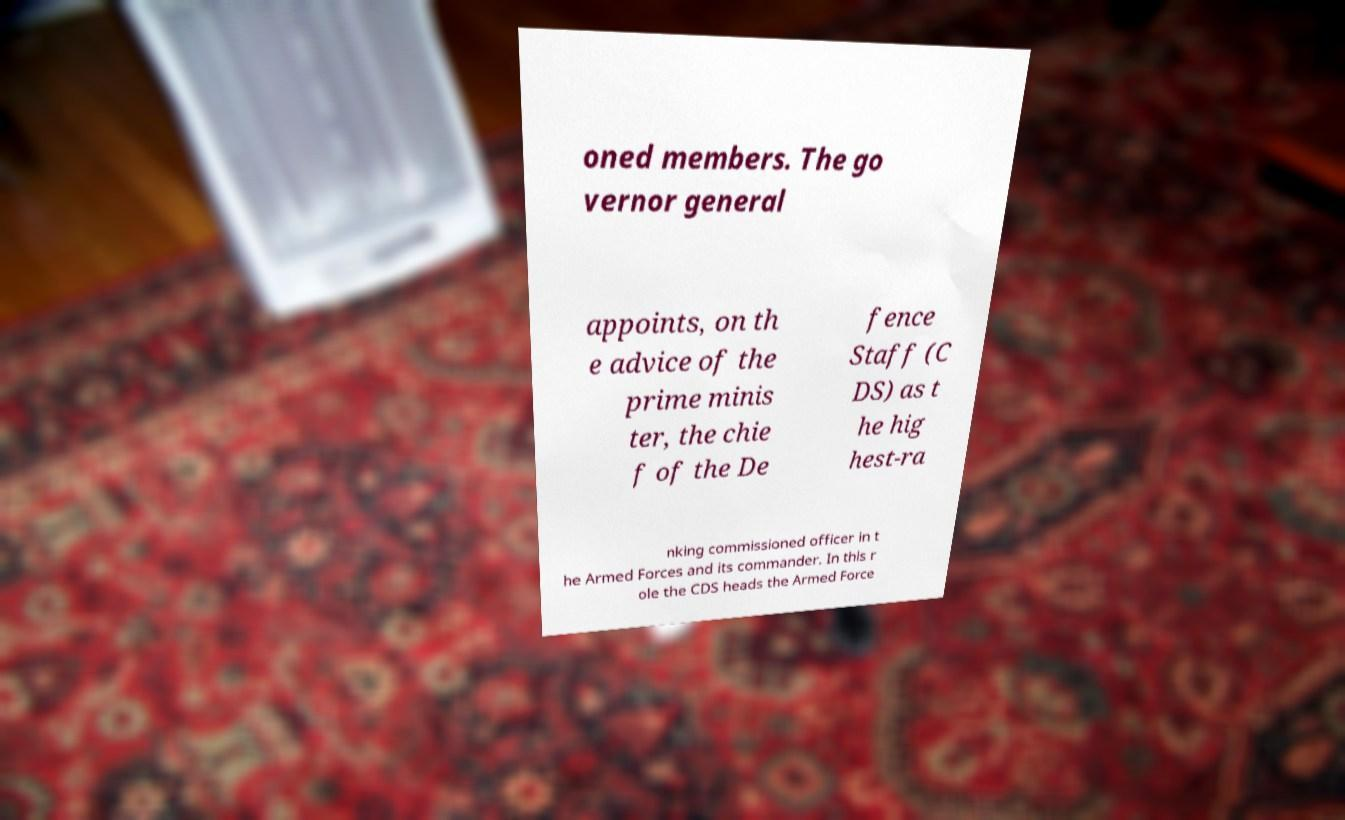Can you accurately transcribe the text from the provided image for me? oned members. The go vernor general appoints, on th e advice of the prime minis ter, the chie f of the De fence Staff (C DS) as t he hig hest-ra nking commissioned officer in t he Armed Forces and its commander. In this r ole the CDS heads the Armed Force 